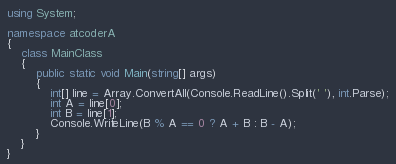Convert code to text. <code><loc_0><loc_0><loc_500><loc_500><_C#_>using System;

namespace atcoderA
{
    class MainClass
    {
        public static void Main(string[] args)
        {
            int[] line = Array.ConvertAll(Console.ReadLine().Split(' '), int.Parse);
            int A = line[0];
            int B = line[1];
            Console.WriteLine(B % A == 0 ? A + B : B - A);
        }
    }
}</code> 